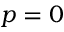<formula> <loc_0><loc_0><loc_500><loc_500>p = 0</formula> 